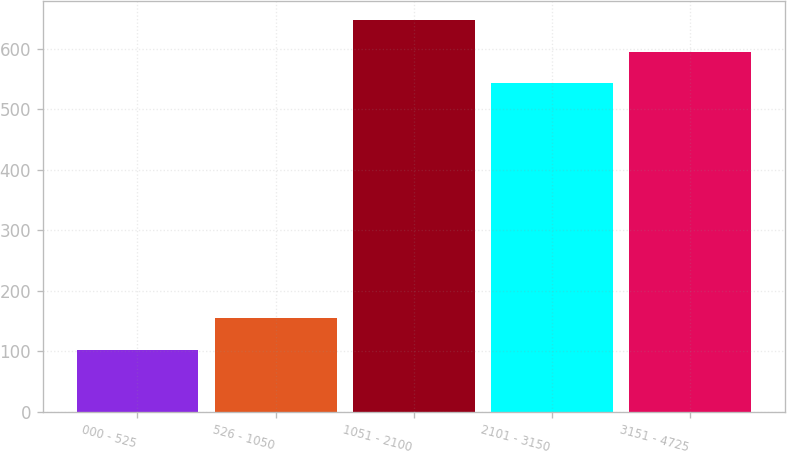Convert chart. <chart><loc_0><loc_0><loc_500><loc_500><bar_chart><fcel>000 - 525<fcel>526 - 1050<fcel>1051 - 2100<fcel>2101 - 3150<fcel>3151 - 4725<nl><fcel>102<fcel>154.3<fcel>647.6<fcel>543<fcel>595.3<nl></chart> 